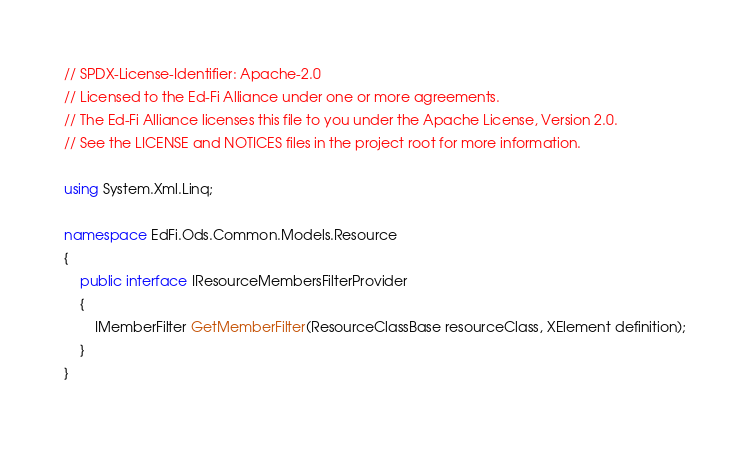<code> <loc_0><loc_0><loc_500><loc_500><_C#_>// SPDX-License-Identifier: Apache-2.0
// Licensed to the Ed-Fi Alliance under one or more agreements.
// The Ed-Fi Alliance licenses this file to you under the Apache License, Version 2.0.
// See the LICENSE and NOTICES files in the project root for more information.

using System.Xml.Linq;

namespace EdFi.Ods.Common.Models.Resource
{
    public interface IResourceMembersFilterProvider
    {
        IMemberFilter GetMemberFilter(ResourceClassBase resourceClass, XElement definition);
    }
}
</code> 